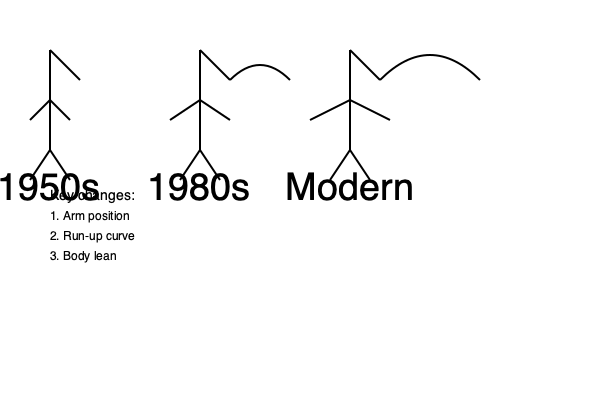Analyze the evolution of fast bowling techniques from the 1950s to the modern era as depicted in the stick figure illustrations. Identify the three key changes shown and explain how these modifications have impacted bowling speed, accuracy, and the overall effectiveness of fast bowlers in cricket. To analyze the evolution of fast bowling techniques, we need to examine the three key changes illustrated in the stick figures:

1. Arm position:
   - 1950s: The bowling arm is relatively straight and close to the body.
   - 1980s: The arm is slightly more bent and away from the body.
   - Modern: The arm is significantly more bent and further away from the body.
   
   Impact: This change allows for greater leverage and whip-like action, increasing bowling speed. It also enables bowlers to generate more spin and variation in their deliveries.

2. Run-up curve:
   - 1950s: The run-up appears to be straight.
   - 1980s: A slight curve is introduced in the run-up.
   - Modern: The run-up has a more pronounced curve.
   
   Impact: The curved run-up helps bowlers generate more momentum and allows for a smoother transition into the delivery stride. This aids in maintaining balance and increasing overall bowling speed.

3. Body lean:
   - 1950s: The body is relatively upright.
   - 1980s: There is a slight forward lean.
   - Modern: The body has a more pronounced forward lean.
   
   Impact: The increased body lean helps bowlers transfer more energy into the delivery and maintain a lower center of gravity. This improves balance and allows for better control over line and length.

These changes have collectively resulted in:

1. Increased bowling speed: The modified arm position, curved run-up, and forward lean all contribute to generating more power and speed in the delivery.

2. Improved accuracy: Better balance and body control from the curved run-up and forward lean allow bowlers to maintain consistency in their line and length.

3. Enhanced variation: The changed arm position enables bowlers to impart more spin and variation on the ball, making it harder for batsmen to predict the delivery.

4. Greater overall effectiveness: The combination of increased speed, improved accuracy, and enhanced variation has made modern fast bowlers more potent and adaptable to different playing conditions and strategies.

These evolutionary changes reflect the growing understanding of biomechanics in cricket and the constant pursuit of improving bowling techniques to gain an edge over batsmen.
Answer: Arm position widened, run-up curved, body lean increased; resulting in higher speed, better accuracy, and more variation. 